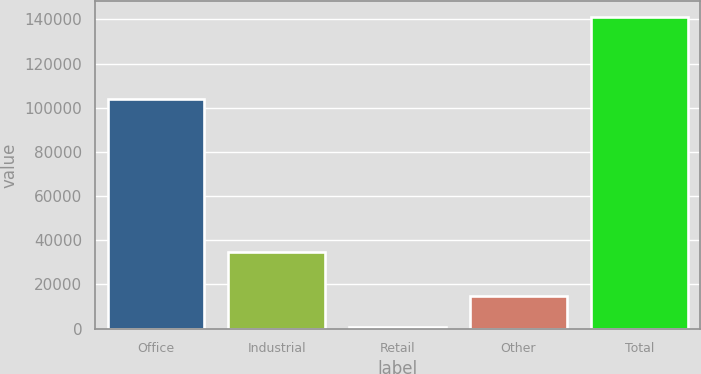Convert chart. <chart><loc_0><loc_0><loc_500><loc_500><bar_chart><fcel>Office<fcel>Industrial<fcel>Retail<fcel>Other<fcel>Total<nl><fcel>104056<fcel>34872<fcel>609<fcel>14670.7<fcel>141226<nl></chart> 